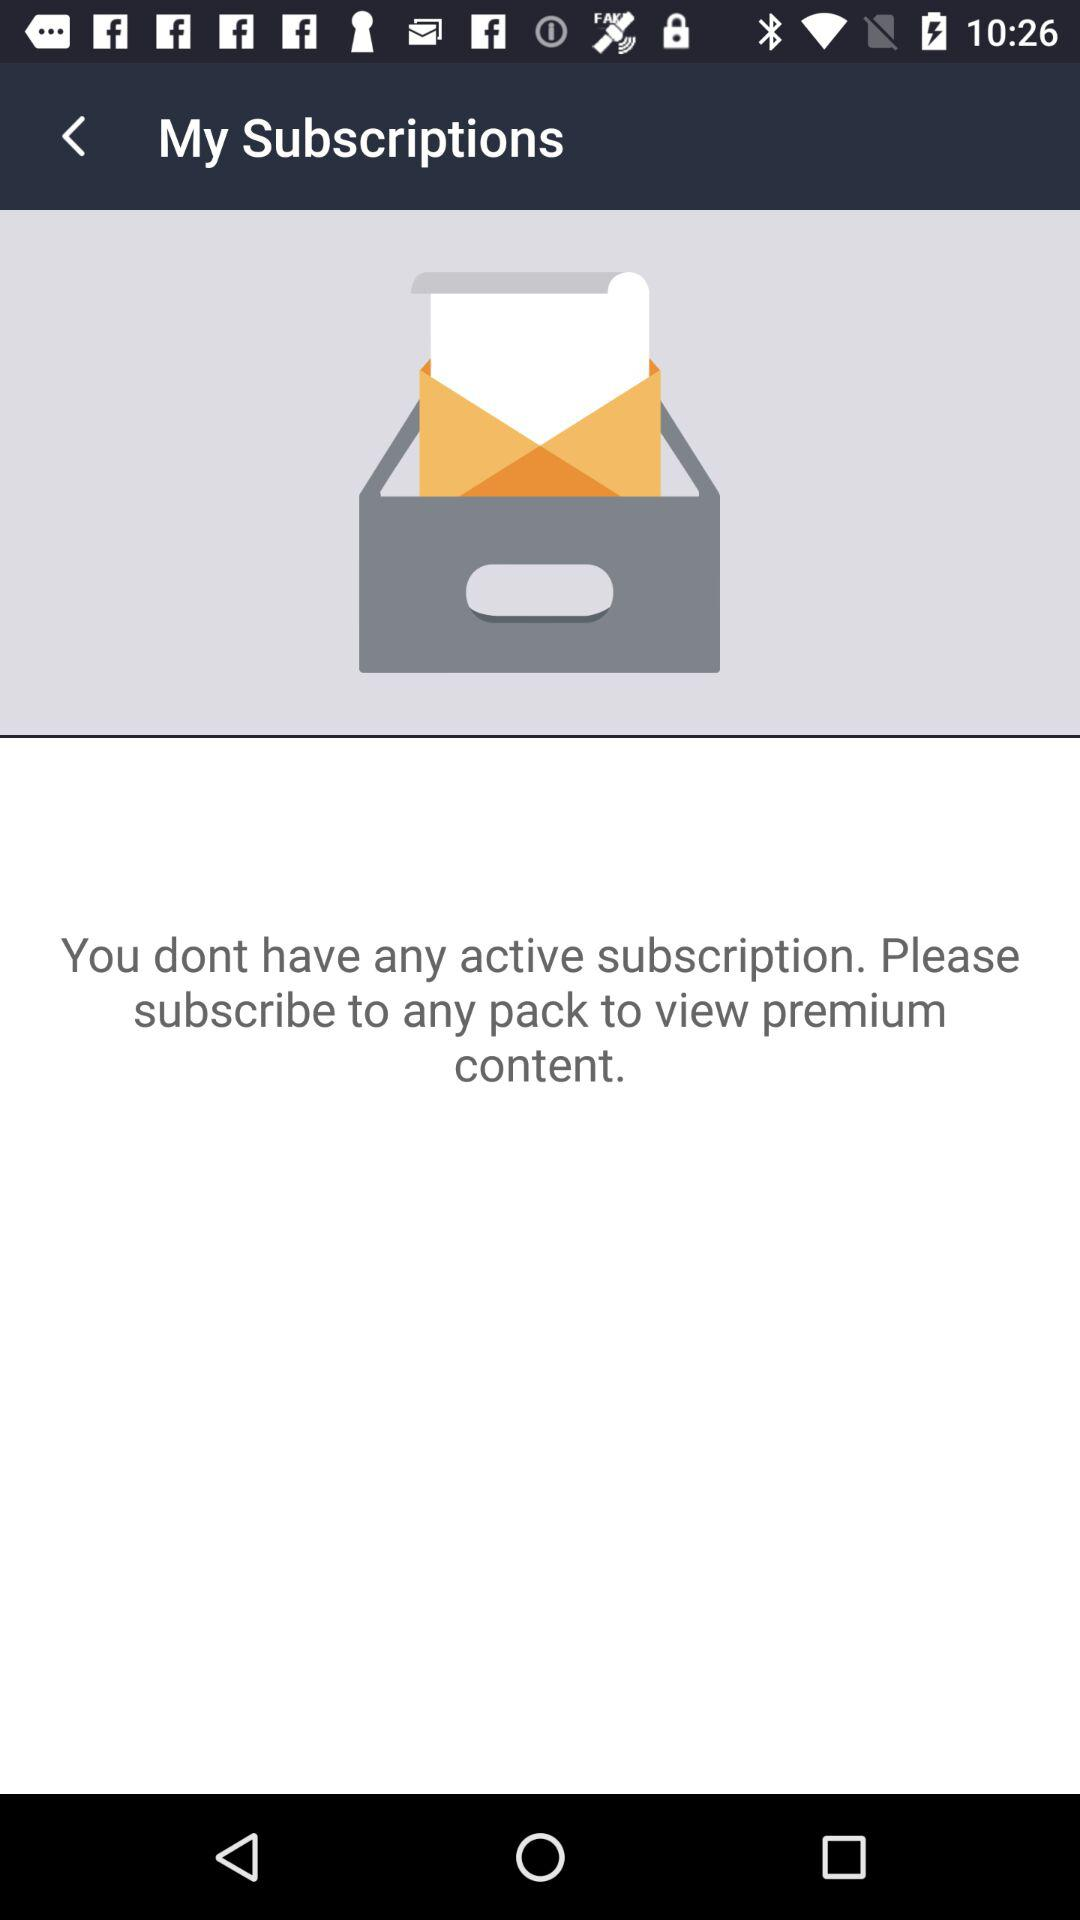How many active subscriptions do I have?
Answer the question using a single word or phrase. 0 